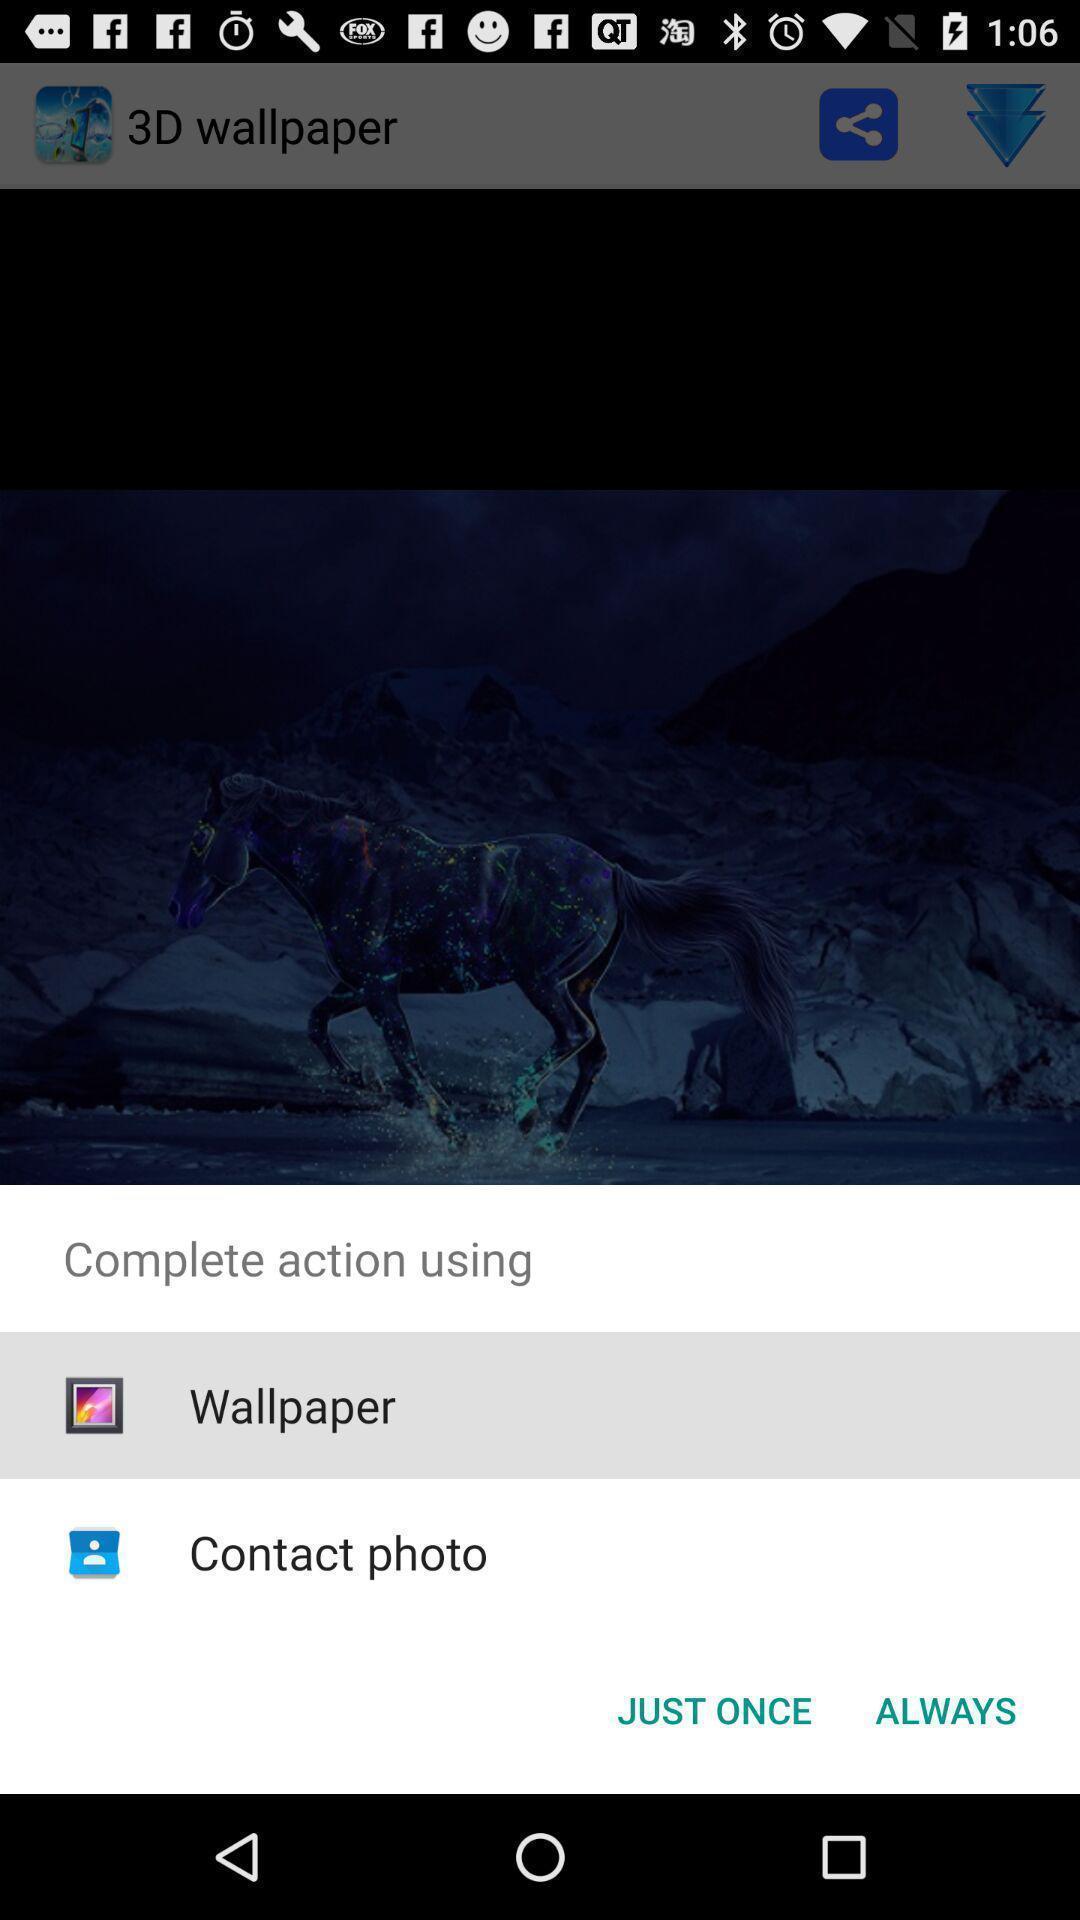Summarize the information in this screenshot. Pop up notification to open the app. 